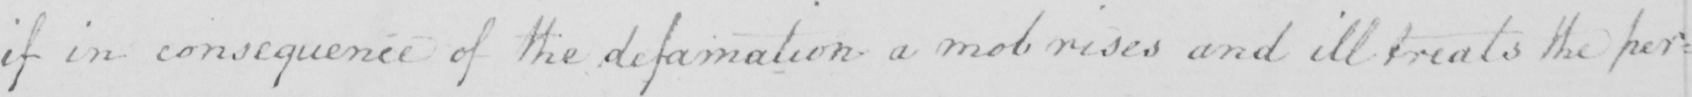Please provide the text content of this handwritten line. if in consequence of the defamation a mob rises and ill treats the per= 